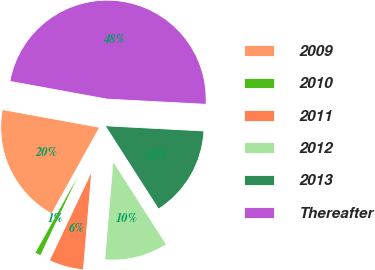<chart> <loc_0><loc_0><loc_500><loc_500><pie_chart><fcel>2009<fcel>2010<fcel>2011<fcel>2012<fcel>2013<fcel>Thereafter<nl><fcel>19.8%<fcel>1.02%<fcel>5.71%<fcel>10.41%<fcel>15.1%<fcel>47.96%<nl></chart> 